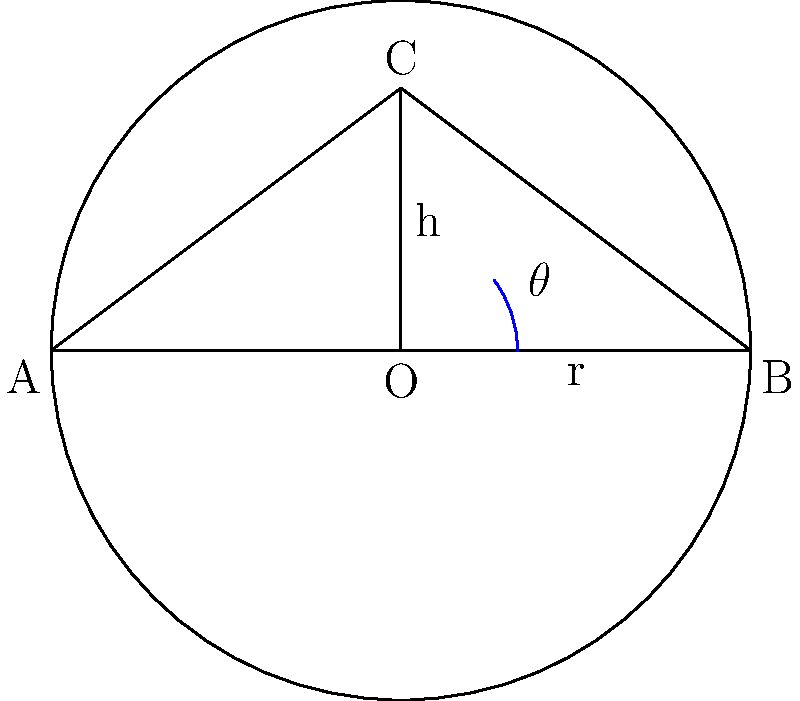During a site investigation, you create a conical pile of sediment with a base radius of 4 meters and a height of 3 meters. What is the angle of repose (θ) for this sediment pile? Round your answer to the nearest degree. To find the angle of repose (θ) for the conical pile of sediment, we can use trigonometry. The problem gives us two key pieces of information:

1. Base radius (r) = 4 meters
2. Height (h) = 3 meters

We can solve this problem using the following steps:

1. Recognize that the angle of repose is the angle between the side of the cone and the horizontal base.

2. The conical pile forms a right triangle, where:
   - The base of the triangle is the radius (r)
   - The height of the triangle is the height of the cone (h)
   - The hypotenuse is the side of the cone

3. We can use the tangent function to find the angle:

   $$\tan(\theta) = \frac{\text{opposite}}{\text{adjacent}} = \frac{h}{r}$$

4. Substitute the known values:

   $$\tan(\theta) = \frac{3}{4}$$

5. To find θ, we need to use the inverse tangent (arctan or tan^(-1)):

   $$\theta = \arctan(\frac{3}{4})$$

6. Calculate the result:

   $$\theta \approx 36.87^\circ$$

7. Rounding to the nearest degree:

   $$\theta \approx 37^\circ$$

Therefore, the angle of repose for this sediment pile is approximately 37°.
Answer: 37° 